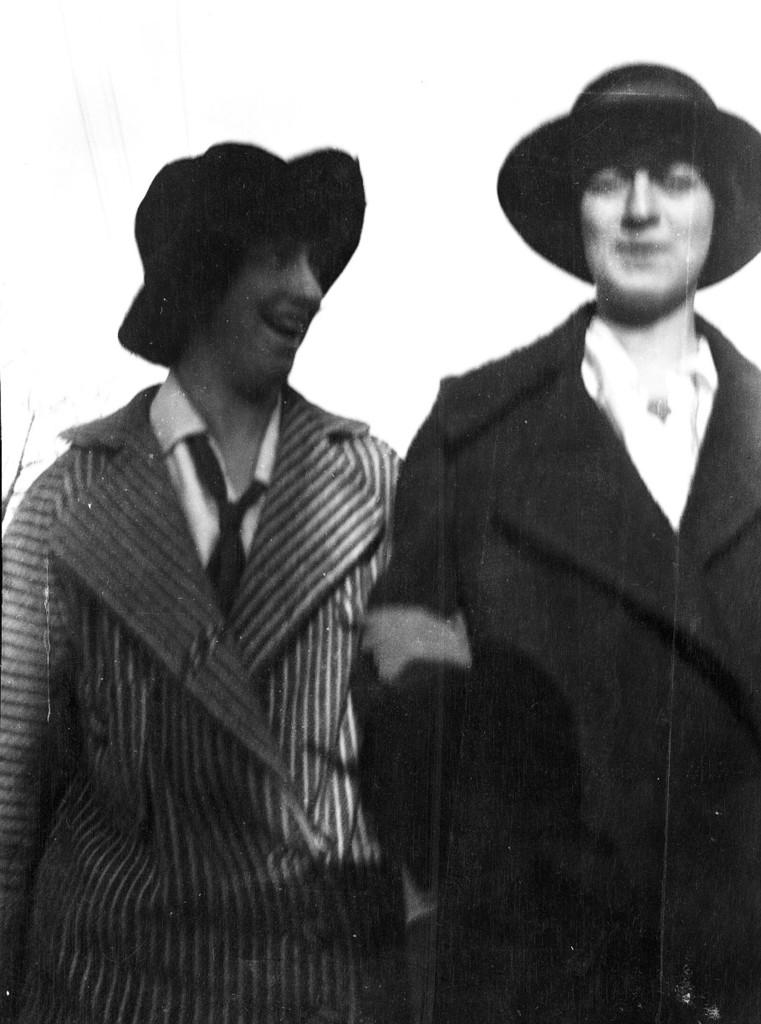How many people are in the image? There are two people in the foreground of the image. What are the people wearing on their heads? Both people are wearing caps. What type of gold creature can be seen in the image? There is no gold creature present in the image. 